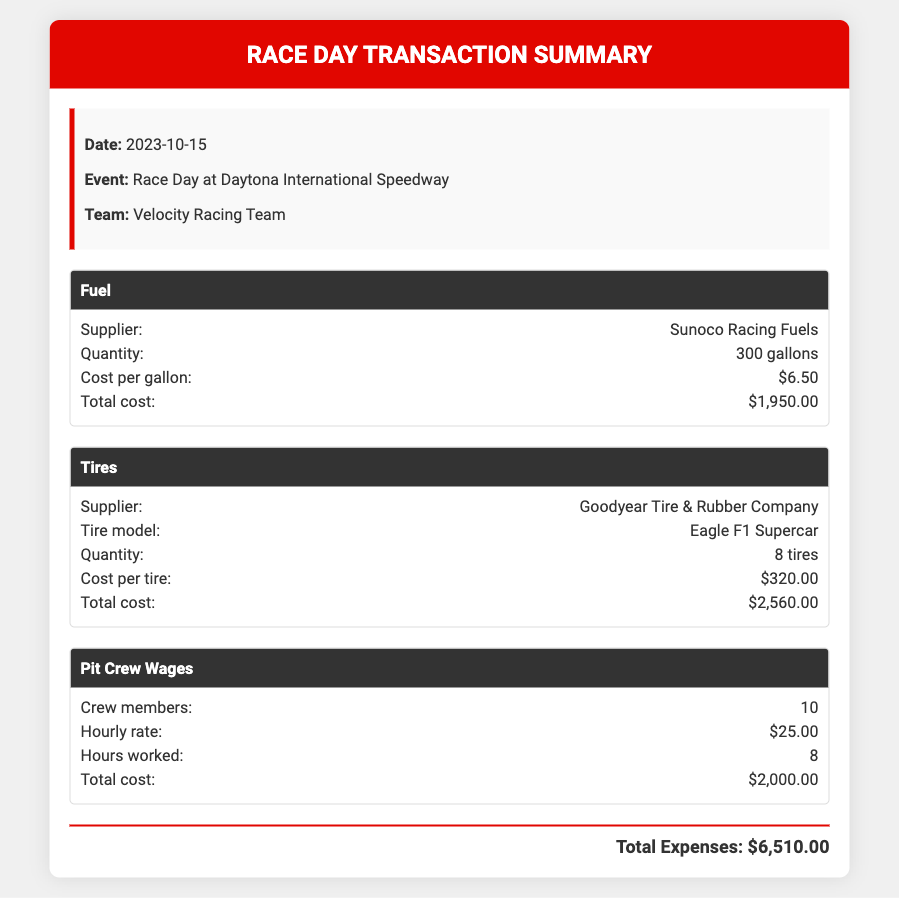What is the date of the event? The date of the event is mentioned in the document under event details.
Answer: 2023-10-15 Who is the supplier of the fuel? The supplier of the fuel is specified in the fuel expense category.
Answer: Sunoco Racing Fuels How many tires were purchased? The quantity of tires purchased is listed in the tire expense category.
Answer: 8 tires What is the total cost of the tires? The total cost is provided for the tire purchase in the respective section.
Answer: $2,560.00 What is the hourly rate for pit crew members? The hourly rate is stated in the pit crew wages section of the document.
Answer: $25.00 How many crew members were involved? The number of crew members is indicated in the pit crew wages section.
Answer: 10 What is the total expense for the race day? The total expenses are summarized at the end of the document.
Answer: $6,510.00 Which tire model was purchased? The tire model is listed in the tire expense section of the document.
Answer: Eagle F1 Supercar What is the total cost for pit crew wages? The total cost for pit crew wages is reported in the respective section of the document.
Answer: $2,000.00 